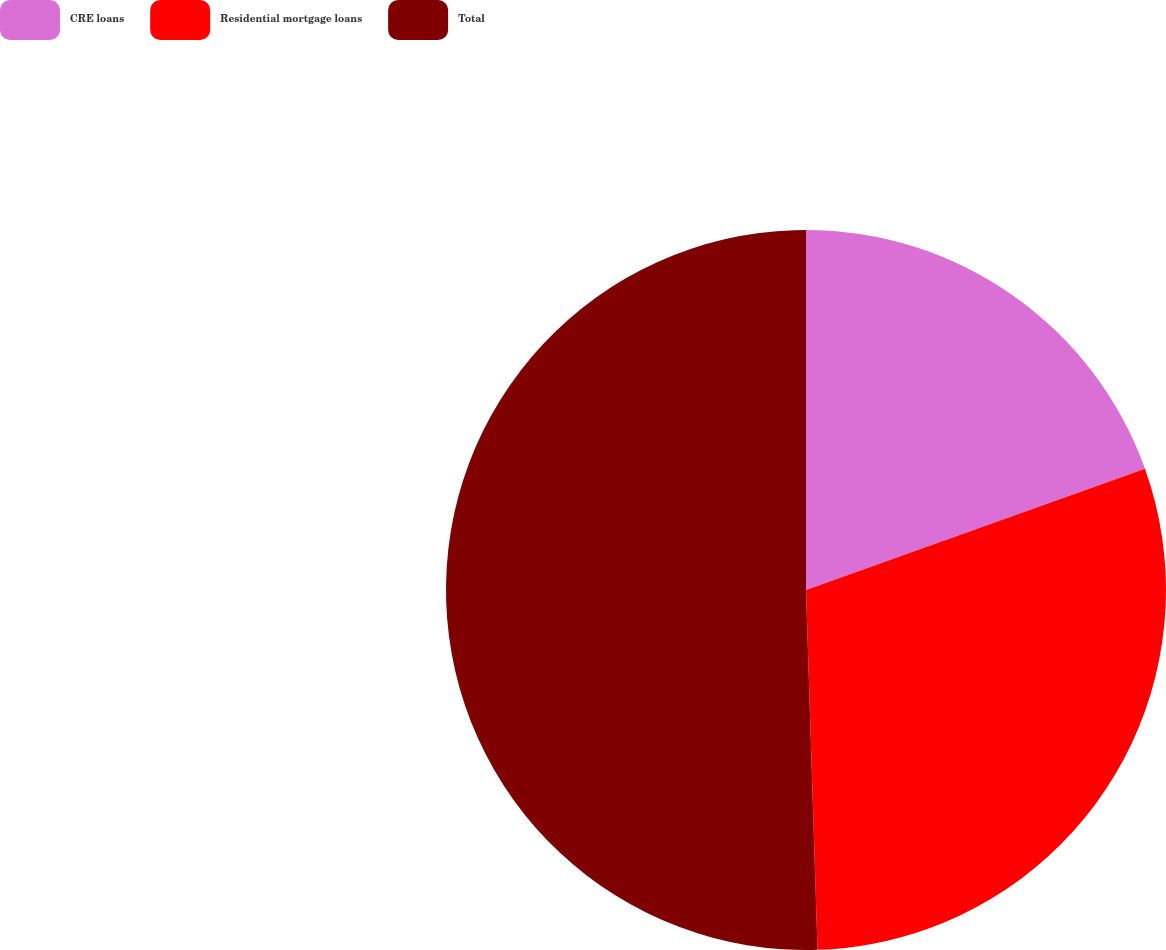Convert chart. <chart><loc_0><loc_0><loc_500><loc_500><pie_chart><fcel>CRE loans<fcel>Residential mortgage loans<fcel>Total<nl><fcel>19.53%<fcel>29.96%<fcel>50.51%<nl></chart> 